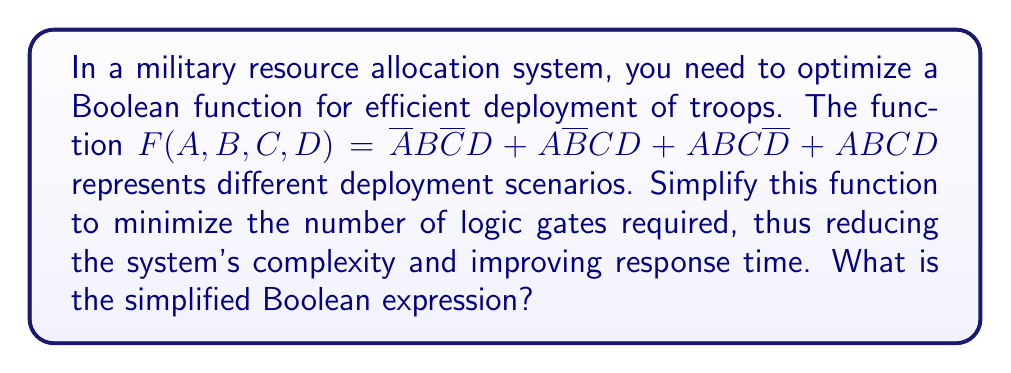Could you help me with this problem? Let's simplify the Boolean function using the laws of Boolean algebra:

1) First, we can factor out $AB$ from the last two terms:
   $F = \overline{A}B\overline{C}D + A\overline{B}CD + AB(C\overline{D} + CD)$

2) Simplify $C\overline{D} + CD$ using the distributive law:
   $C\overline{D} + CD = C(\overline{D} + D) = C$

3) Substituting back:
   $F = \overline{A}B\overline{C}D + A\overline{B}CD + ABC$

4) Now, we can factor out $D$ from the first two terms:
   $F = D(\overline{A}B\overline{C} + A\overline{B}C) + ABC$

5) The term $\overline{A}B\overline{C} + A\overline{B}C$ can be recognized as the exclusive OR (XOR) of $A$ and $C$ ANDed with $B$. We can write this as $(A \oplus C)B$.

6) Therefore, our final simplified expression is:
   $F = D(A \oplus C)B + ABC$

This simplified form reduces the number of logic gates required, optimizing the resource allocation system.
Answer: $F = D(A \oplus C)B + ABC$ 